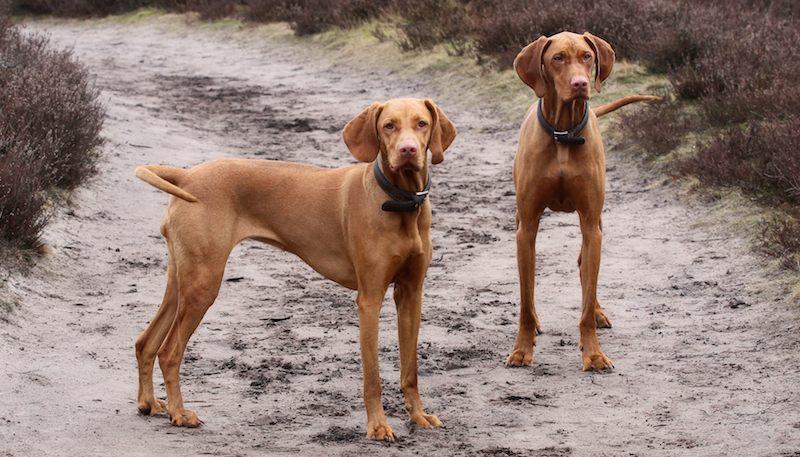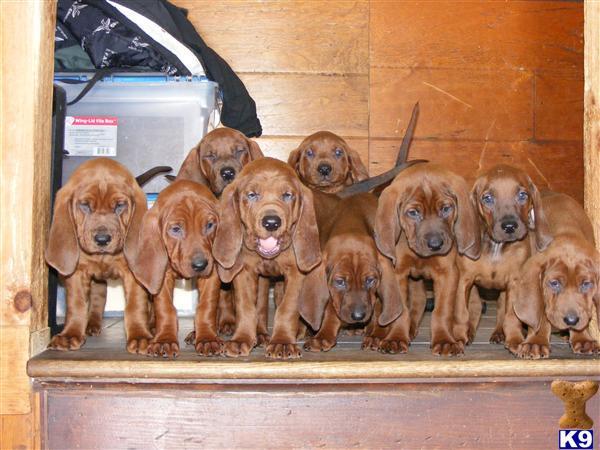The first image is the image on the left, the second image is the image on the right. Assess this claim about the two images: "There is a total of three dogs.". Correct or not? Answer yes or no. No. The first image is the image on the left, the second image is the image on the right. Given the left and right images, does the statement "There are two dogs in the left image." hold true? Answer yes or no. Yes. 